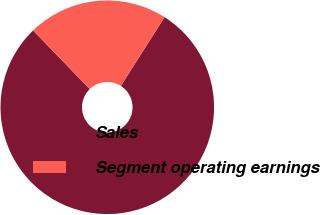Convert chart. <chart><loc_0><loc_0><loc_500><loc_500><pie_chart><fcel>Sales<fcel>Segment operating earnings<nl><fcel>78.77%<fcel>21.23%<nl></chart> 